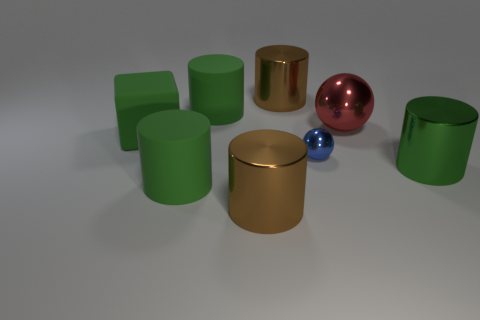Is there any other thing that has the same size as the blue metal thing?
Keep it short and to the point. No. Does the blue thing have the same shape as the big red object?
Provide a succinct answer. Yes. There is a metal object that is both behind the tiny object and to the left of the red shiny object; what color is it?
Your answer should be compact. Brown. What is the size of the metallic object that is the same color as the matte cube?
Your answer should be compact. Large. Are there any other things that are the same color as the large ball?
Your response must be concise. No. There is a large green thing that is right of the brown shiny cylinder in front of the brown shiny object behind the large green metallic cylinder; what is it made of?
Make the answer very short. Metal. There is a large thing right of the red metal thing; is its color the same as the large cube?
Ensure brevity in your answer.  Yes. Is the material of the red object the same as the tiny object?
Make the answer very short. Yes. Are there an equal number of big red shiny spheres that are behind the red metal object and green metal things that are behind the small object?
Ensure brevity in your answer.  Yes. There is a large red object that is the same shape as the blue shiny thing; what material is it?
Make the answer very short. Metal. 